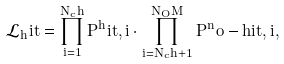Convert formula to latex. <formula><loc_0><loc_0><loc_500><loc_500>\mathcal { L } _ { h } i t = \prod _ { i = 1 } ^ { N _ { c } h } { P } ^ { h } i t , i \cdot \prod _ { i = N _ { c } h + 1 } ^ { N _ { O } M } { P } ^ { n } o - h i t , i ,</formula> 